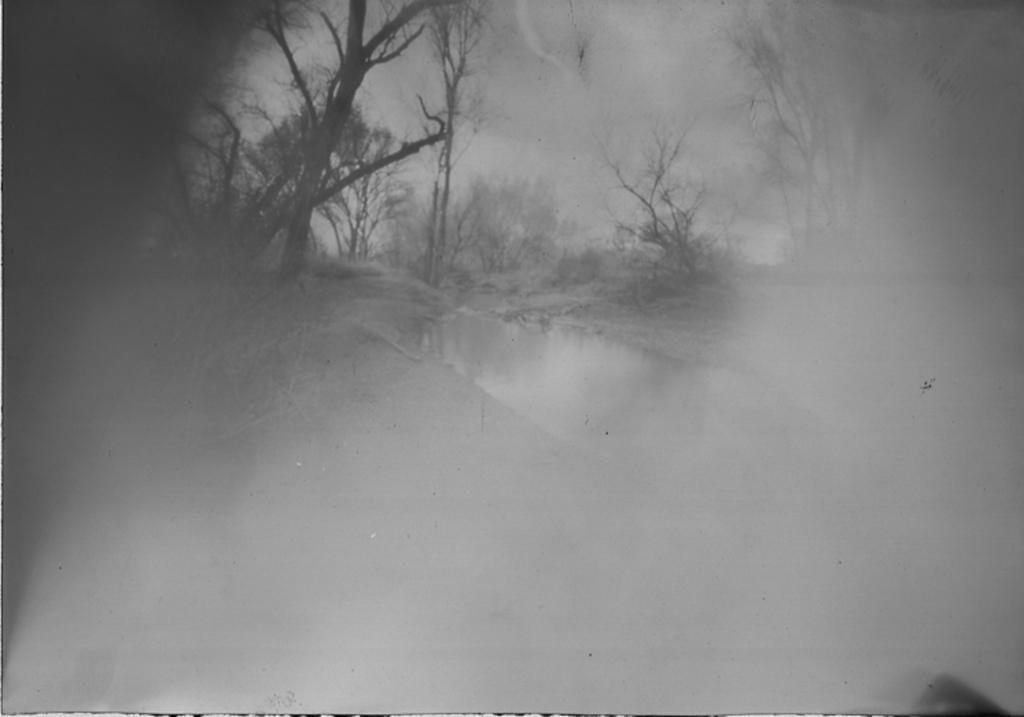Could you give a brief overview of what you see in this image? In the image we can see fog. Behind the fog there is water and trees. 